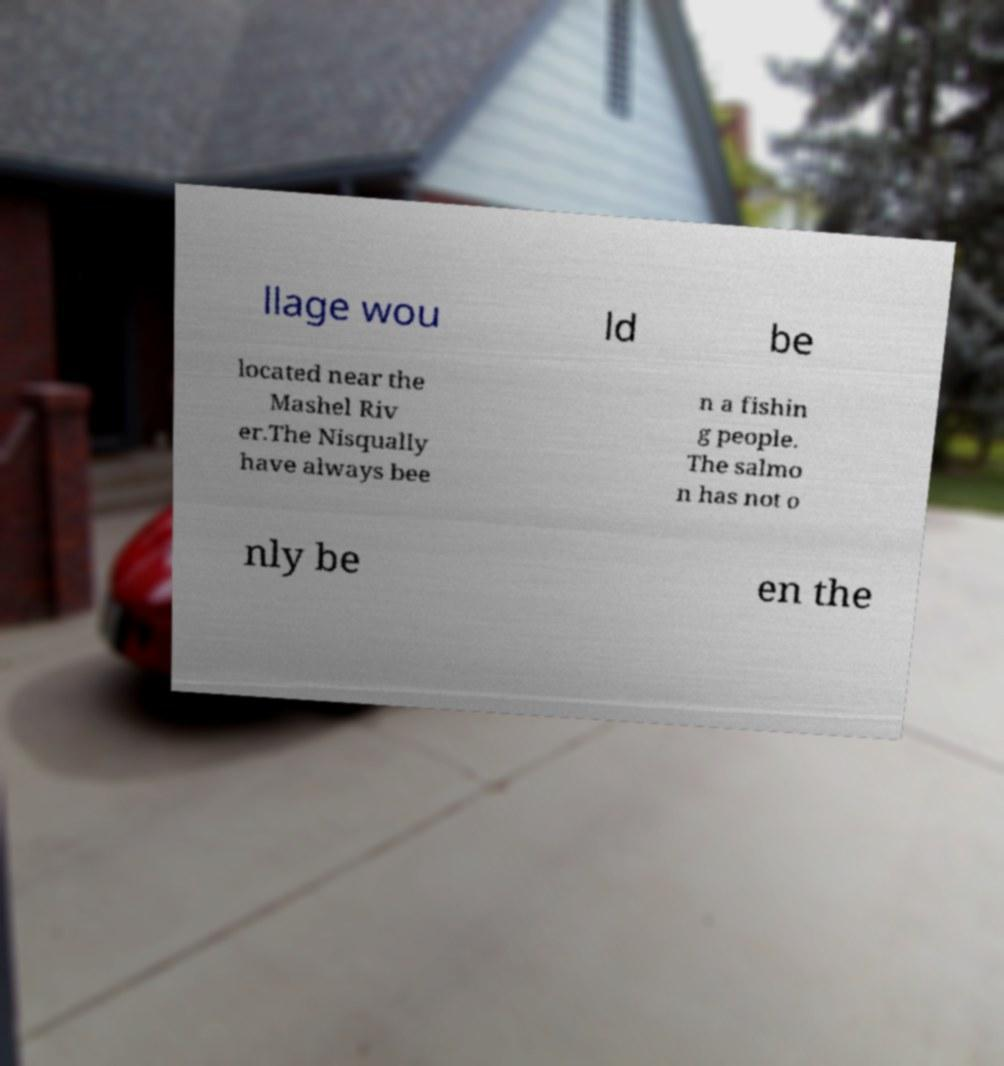What messages or text are displayed in this image? I need them in a readable, typed format. llage wou ld be located near the Mashel Riv er.The Nisqually have always bee n a fishin g people. The salmo n has not o nly be en the 